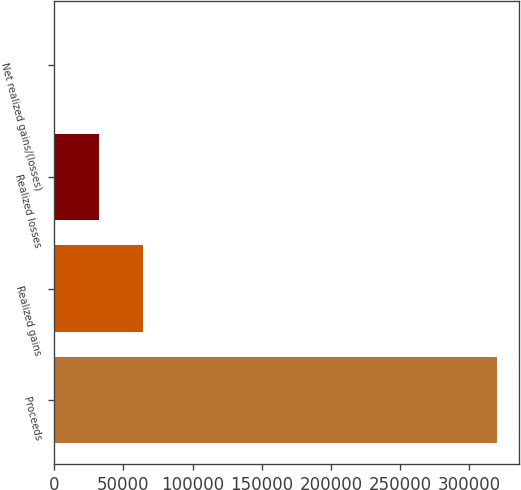Convert chart to OTSL. <chart><loc_0><loc_0><loc_500><loc_500><bar_chart><fcel>Proceeds<fcel>Realized gains<fcel>Realized losses<fcel>Net realized gains/(losses)<nl><fcel>319711<fcel>64249.4<fcel>32316.7<fcel>384<nl></chart> 